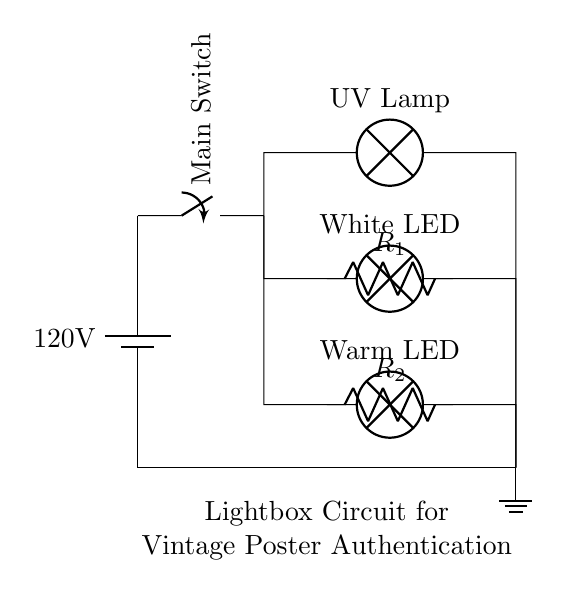What is the main voltage used in this circuit? The main voltage is depicted as 120 volts, showing the potential difference provided by the battery in the circuit.
Answer: 120 volts What types of lamps are included in the circuit? There are three types of lamps shown: a UV Lamp, a White LED, and a Warm LED. The labels next to each lamp component indicate their types.
Answer: UV Lamp, White LED, Warm LED How many resistors are present, and what do they do? There are two resistors present in the circuit, used for current limiting of the LEDs. The resistors help to prevent excess current from damaging the LED components.
Answer: Two resistors What is the purpose of the main switch in the circuit? The main switch controls the flow of electricity through the circuit, allowing the user to turn the entire lightbox on or off. It acts as a safety and operational feature.
Answer: Control power What is the total number of parallel branches in the circuit? The circuit features three parallel branches, each supplying power to a distinct lighting source (the three types of lamps).
Answer: Three branches If one lamp fails, what happens to the current in the other lamps? If one lamp fails, the current continues to flow through the remaining lamps, as they are wired in parallel. This ensures that other lights remain operational.
Answer: Other lamps stay on 